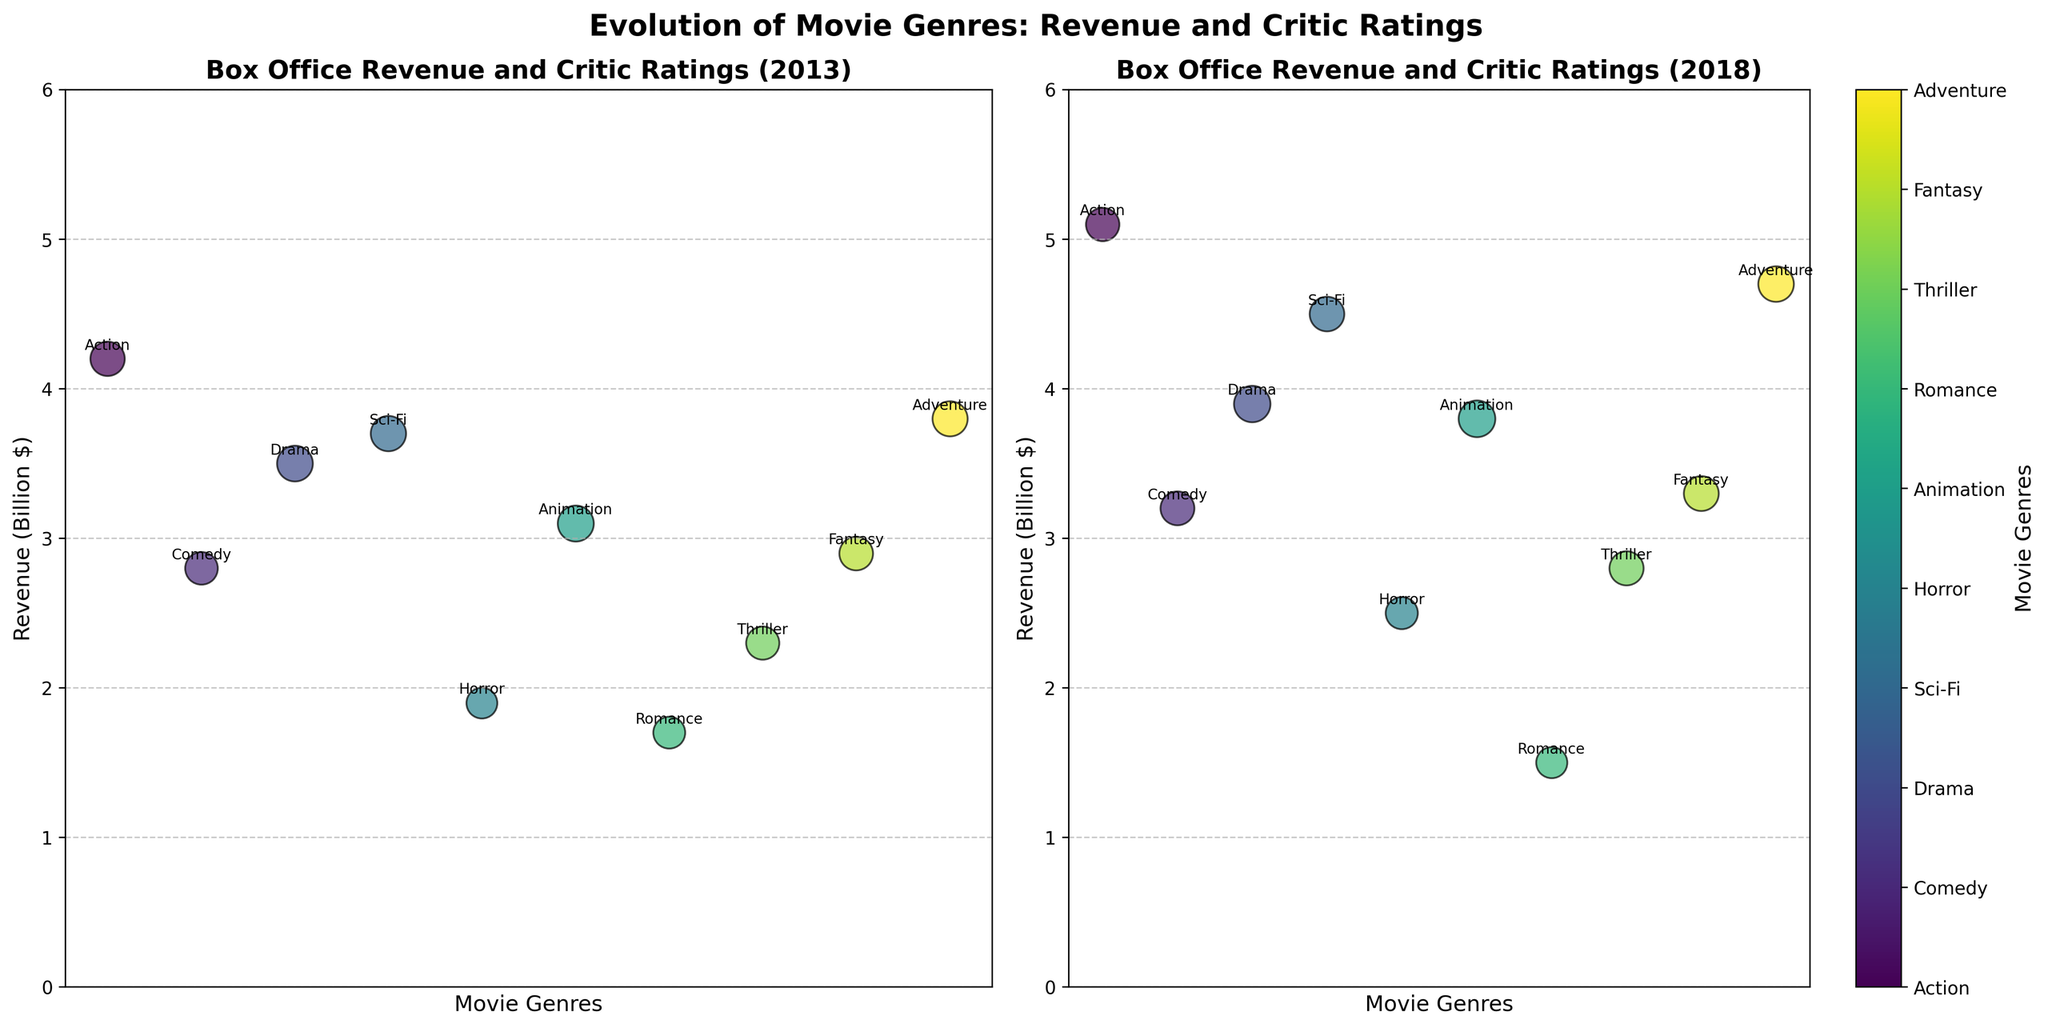What's the title of the figure? The title is located at the top center of the figure and is meant to give an overview of what data the plot represents.
Answer: Evolution of Movie Genres: Revenue and Critic Ratings Which genre had the highest revenue in 2013? To determine this, look for the largest y-value (revenue) among the genres in the 2013 subplot (left side).
Answer: Action Which genre saw a decrease in revenue from 2013 to 2018? Compare the y-values (revenues) for each genre between the 2013 subplot and the 2018 subplot. Romance in the 2013 subplot had higher revenue compared to the 2018 subplot.
Answer: Romance Which genre has the highest critic rating in 2018? Check the bubble size in the 2018 subplot and find the largest one. The genre associated with it has the highest rating.
Answer: Animation Is there a genre with both increasing revenue and increasing critic ratings from 2013 to 2018? Look for a genre that has higher y-values (revenue) and larger bubble size (critic rating) in the 2018 subplot compared to the 2013 subplot.
Answer: Drama, Thriller, Animation What's the difference in revenue between Action and Comedy genres in 2018? Identify the revenue for both genres in the 2018 subplot and subtract the Comedy’s revenue from Action’s revenue. Action has 5.1 billion dollars, Comedy has 3.2 billion dollars, so the difference is 5.1 - 3.2 = 1.9 billion dollars.
Answer: 1.9 Which genre has the smallest revenue in both years? Look for the genre with the smallest y-value (revenue) in both subplots and compare them.
Answer: Romance Did the critic rating for Sci-Fi increase or decrease from 2013 to 2018? Compare the sizes of the bubbles representing the Sci-Fi genre between 2013 and 2018. The size decreased from 76 to 73.
Answer: Decrease Which genre shows the most significant increase in revenue from 2013 to 2018? Compare the y-values for all genres across both years and find the genre with the largest difference. Adventure had the most notable increase from 3.8 to 4.7 billion dollars.
Answer: Adventure 